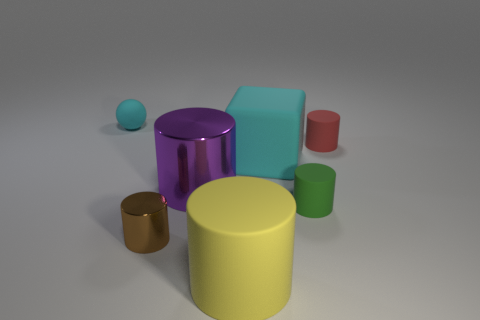Is there any other thing that is the same shape as the tiny cyan rubber object?
Offer a terse response. No. What number of brown objects are behind the tiny green cylinder?
Your answer should be very brief. 0. Are the block and the green thing that is in front of the small red object made of the same material?
Make the answer very short. Yes. What size is the yellow cylinder that is made of the same material as the red object?
Ensure brevity in your answer.  Large. Is the number of tiny cylinders on the left side of the cyan rubber block greater than the number of red rubber objects left of the tiny shiny thing?
Provide a short and direct response. Yes. Are there any big purple shiny objects that have the same shape as the green thing?
Keep it short and to the point. Yes. Does the cyan matte object left of the yellow matte cylinder have the same size as the big cyan block?
Ensure brevity in your answer.  No. Are there any red things?
Your response must be concise. Yes. How many objects are things that are left of the purple thing or shiny things?
Keep it short and to the point. 3. Do the tiny sphere and the large rubber thing behind the small shiny cylinder have the same color?
Offer a terse response. Yes. 